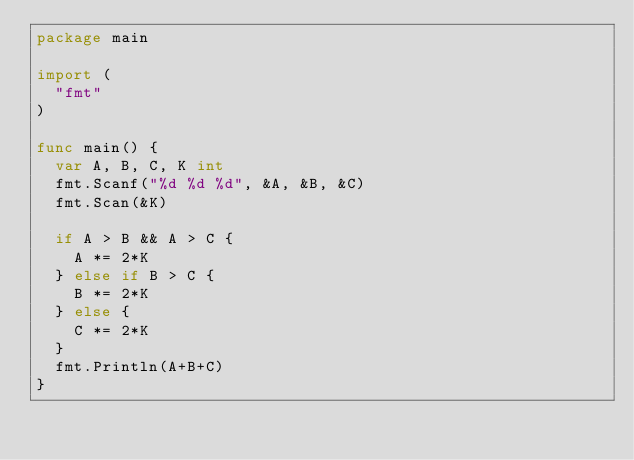<code> <loc_0><loc_0><loc_500><loc_500><_Go_>package main

import (
	"fmt"
)

func main() {
	var A, B, C, K int
	fmt.Scanf("%d %d %d", &A, &B, &C)
	fmt.Scan(&K)

	if A > B && A > C {
		A *= 2*K
	} else if B > C {
		B *= 2*K
	} else {
		C *= 2*K
	}
	fmt.Println(A+B+C)
}
</code> 